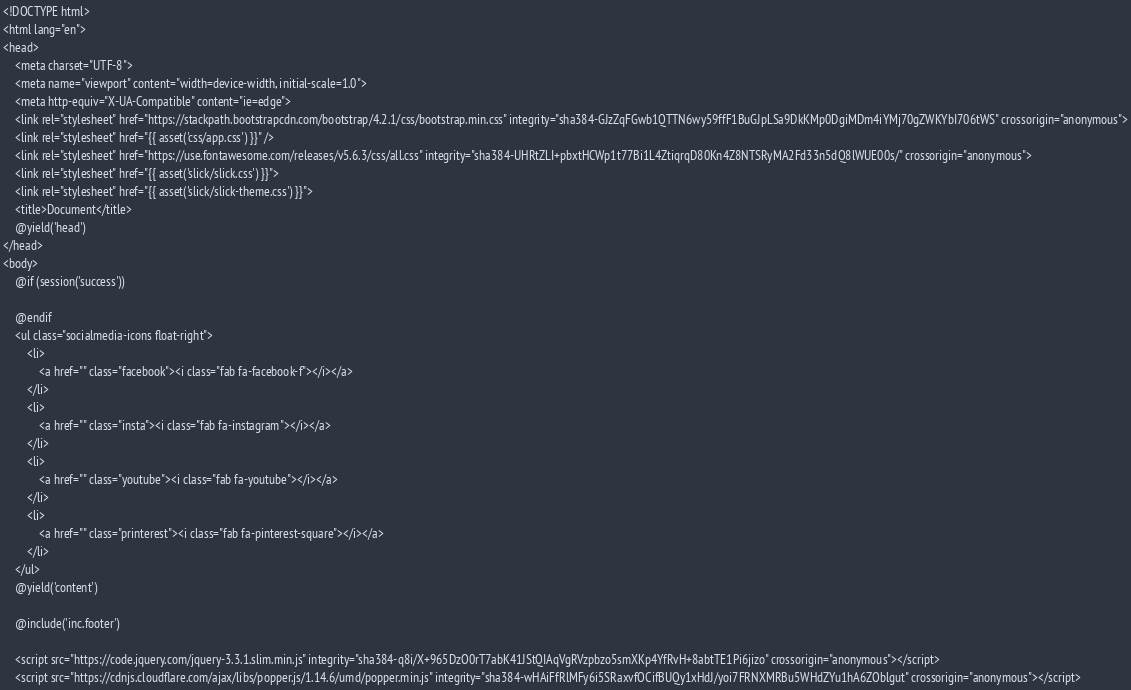<code> <loc_0><loc_0><loc_500><loc_500><_PHP_><!DOCTYPE html>
<html lang="en">
<head>
    <meta charset="UTF-8">
    <meta name="viewport" content="width=device-width, initial-scale=1.0">
    <meta http-equiv="X-UA-Compatible" content="ie=edge">
    <link rel="stylesheet" href="https://stackpath.bootstrapcdn.com/bootstrap/4.2.1/css/bootstrap.min.css" integrity="sha384-GJzZqFGwb1QTTN6wy59ffF1BuGJpLSa9DkKMp0DgiMDm4iYMj70gZWKYbI706tWS" crossorigin="anonymous">
    <link rel="stylesheet" href="{{ asset('css/app.css') }}" />
    <link rel="stylesheet" href="https://use.fontawesome.com/releases/v5.6.3/css/all.css" integrity="sha384-UHRtZLI+pbxtHCWp1t77Bi1L4ZtiqrqD80Kn4Z8NTSRyMA2Fd33n5dQ8lWUE00s/" crossorigin="anonymous">
    <link rel="stylesheet" href="{{ asset('slick/slick.css') }}">
    <link rel="stylesheet" href="{{ asset('slick/slick-theme.css') }}">
    <title>Document</title>
    @yield('head')
</head>
<body>
    @if (session('success'))
        
    @endif
    <ul class="socialmedia-icons float-right">
        <li>
            <a href="" class="facebook"><i class="fab fa-facebook-f"></i></a>
        </li>
        <li>
            <a href="" class="insta"><i class="fab fa-instagram"></i></a>
        </li>
        <li>
            <a href="" class="youtube"><i class="fab fa-youtube"></i></a>
        </li>
        <li>
            <a href="" class="printerest"><i class="fab fa-pinterest-square"></i></a>
        </li>
    </ul>
    @yield('content')
    
    @include('inc.footer')
    
    <script src="https://code.jquery.com/jquery-3.3.1.slim.min.js" integrity="sha384-q8i/X+965DzO0rT7abK41JStQIAqVgRVzpbzo5smXKp4YfRvH+8abtTE1Pi6jizo" crossorigin="anonymous"></script>
    <script src="https://cdnjs.cloudflare.com/ajax/libs/popper.js/1.14.6/umd/popper.min.js" integrity="sha384-wHAiFfRlMFy6i5SRaxvfOCifBUQy1xHdJ/yoi7FRNXMRBu5WHdZYu1hA6ZOblgut" crossorigin="anonymous"></script></code> 